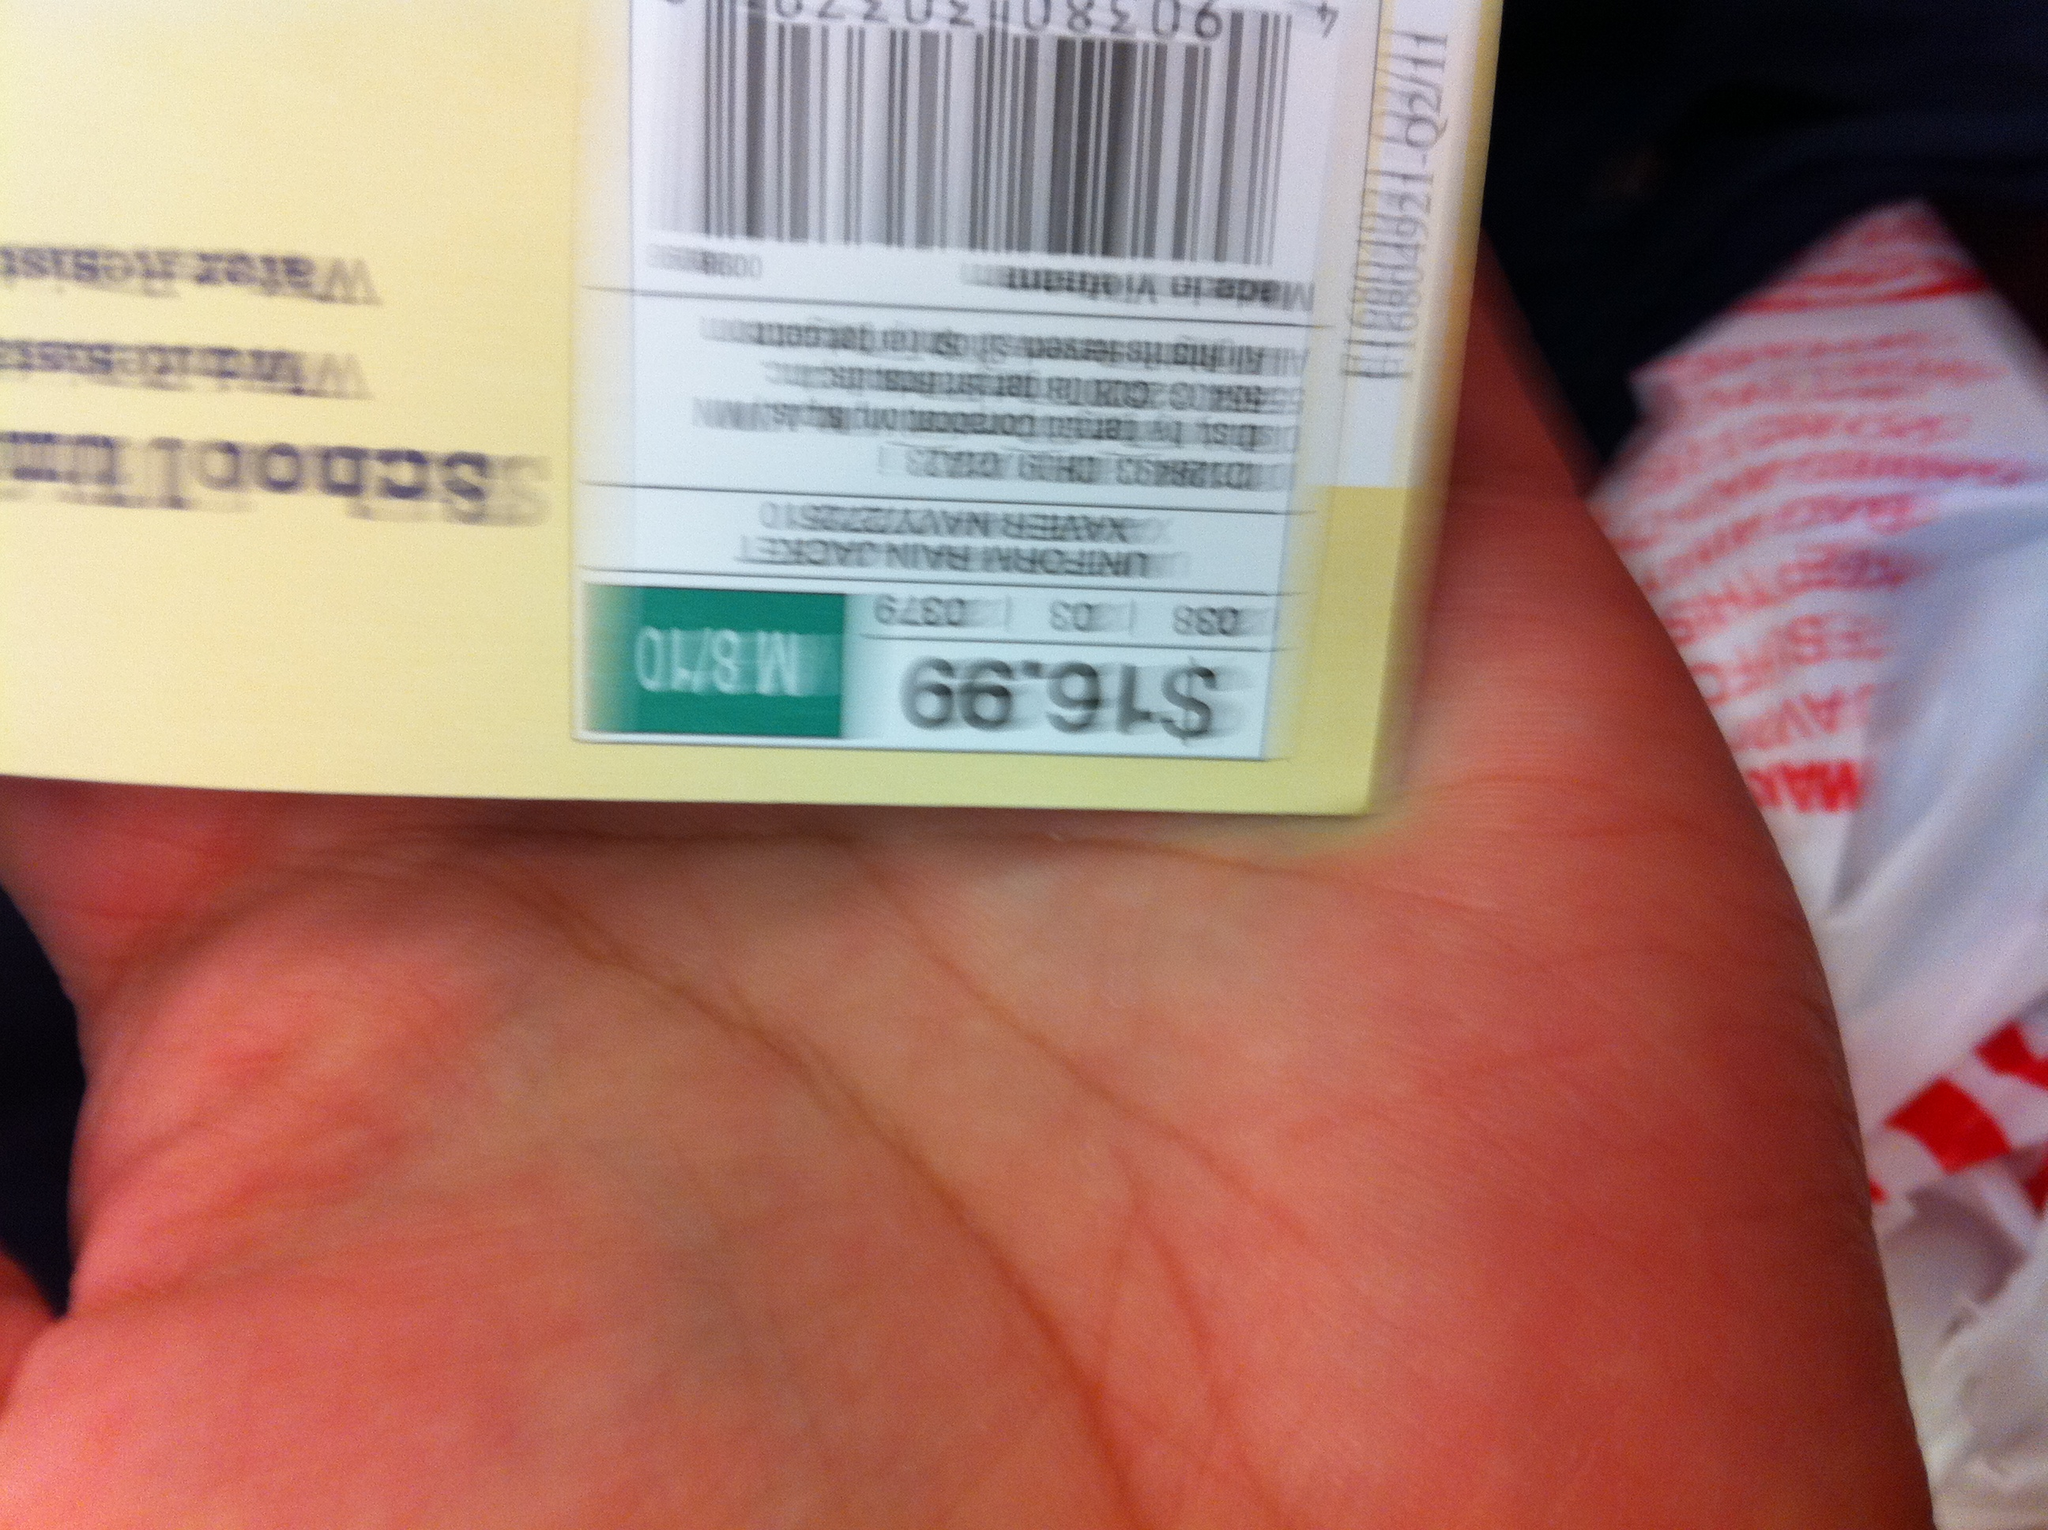What's on the tag? from Vizwiz $16.99 